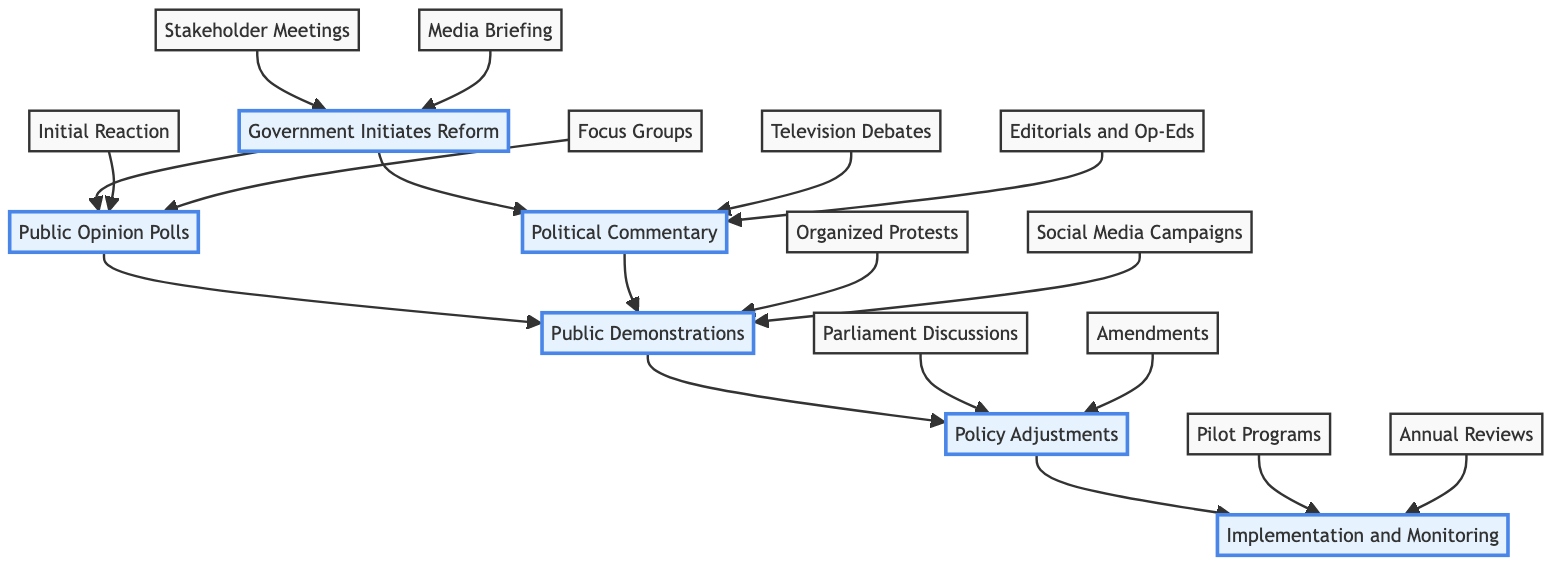What is the first node in the diagram? The first node is "Government Initiates Reform." It is the starting point of the clinical pathway, indicating where the process of public reactions to healthcare reforms begins.
Answer: Government Initiates Reform How many sub-elements are under "Public Opinion Polls"? "Public Opinion Polls" has two sub-elements: "Initial Reaction" and "Focus Groups." This is determined by counting how many direct descendants the node has.
Answer: 2 Which node leads to "Policy Adjustments"? "Public Demonstrations" and "Political Commentary" both lead to "Policy Adjustments." This is verified by tracing the edges in the diagram that connect these nodes.
Answer: Public Demonstrations, Political Commentary What are the two main components of "Implementation and Monitoring"? The two main components are "Pilot Programs" and "Annual Reviews." I can find these by looking at the sub-elements connected to this node.
Answer: Pilot Programs, Annual Reviews After "Public Demonstrations," which node comes next? The next node after "Public Demonstrations" is "Policy Adjustments." This is established by following the directed edge from "Public Demonstrations" to "Policy Adjustments."
Answer: Policy Adjustments How are "Stakeholder Meetings" and "Media Briefing" related to the diagram? Both "Stakeholder Meetings" and "Media Briefing" are sub-elements of "Government Initiates Reform," indicating steps taken by the government before public feedback. This relationships are clearly laid out in the hierarchy of nodes and connections.
Answer: Government Initiates Reform Which elements are involved in the analysis of public sentiment? The elements involved in analyzing public sentiment are "Public Opinion Polls" and its sub-elements: "Initial Reaction" and "Focus Groups." By examining nodes and their definitions, we can see they directly relate to public sentiment.
Answer: Public Opinion Polls, Initial Reaction, Focus Groups What is the relationship between "Media Briefing" and "Public Opinion Polls"? There is no direct relationship, as "Media Briefing" is part of "Government Initiates Reform," while "Public Opinion Polls" branches off from that node. They are connected indirectly through the larger process of healthcare reform but do not connect directly.
Answer: No direct relationship How does "Parliament Discussions" influence the pathway? "Parliament Discussions" influences the pathway as part of the "Policy Adjustments" stage, where discussions and votes can change the proposed reforms based on public and political feedback. It serves as a critical point where political action is considered.
Answer: Policy Adjustments 